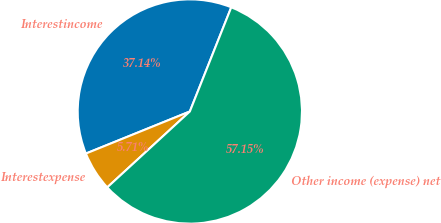Convert chart. <chart><loc_0><loc_0><loc_500><loc_500><pie_chart><fcel>Interestincome<fcel>Interestexpense<fcel>Other income (expense) net<nl><fcel>37.14%<fcel>5.71%<fcel>57.14%<nl></chart> 